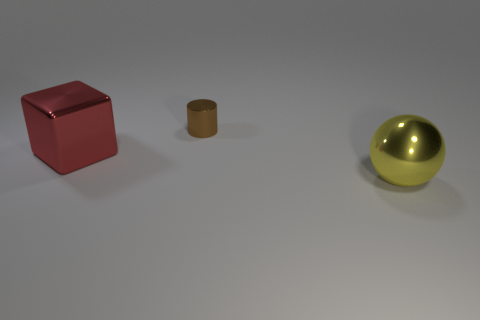What materials do the objects in the image seem to be made of? Based on the image, the red cube appears to have a matte surface, which could suggest a painted metal or plastic, while the small brown cylinder has a more muted finish, potentially indicative of an oxidized metal. The sphere has a highly reflective surface, implying that it's made of a polished metal, perhaps brass or gold-plated steel. 